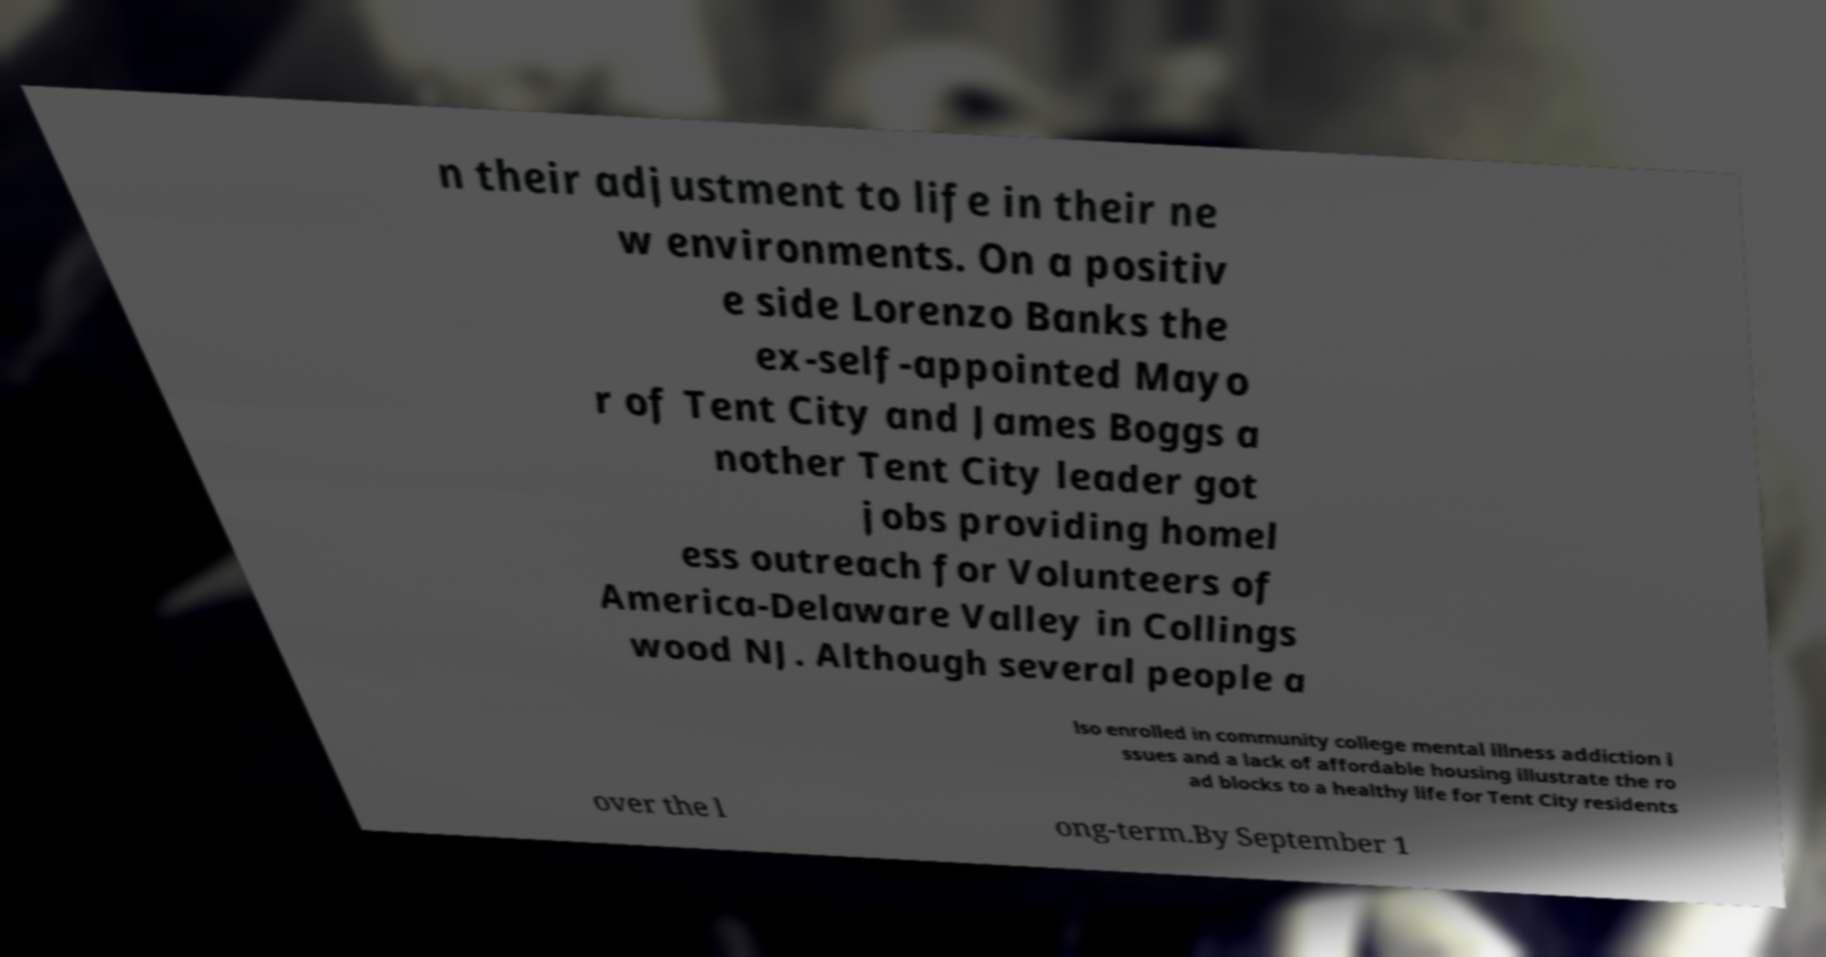Please read and relay the text visible in this image. What does it say? n their adjustment to life in their ne w environments. On a positiv e side Lorenzo Banks the ex-self-appointed Mayo r of Tent City and James Boggs a nother Tent City leader got jobs providing homel ess outreach for Volunteers of America-Delaware Valley in Collings wood NJ. Although several people a lso enrolled in community college mental illness addiction i ssues and a lack of affordable housing illustrate the ro ad blocks to a healthy life for Tent City residents over the l ong-term.By September 1 